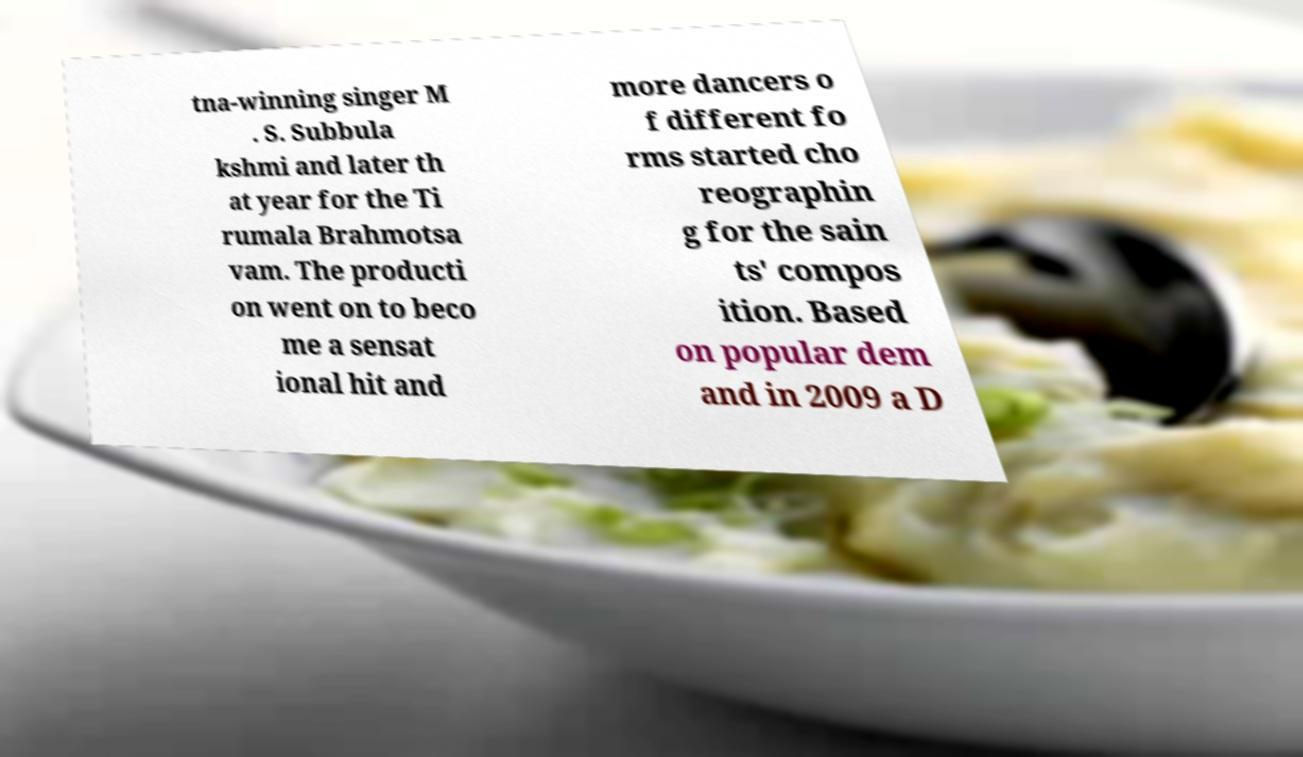Please read and relay the text visible in this image. What does it say? tna-winning singer M . S. Subbula kshmi and later th at year for the Ti rumala Brahmotsa vam. The producti on went on to beco me a sensat ional hit and more dancers o f different fo rms started cho reographin g for the sain ts' compos ition. Based on popular dem and in 2009 a D 